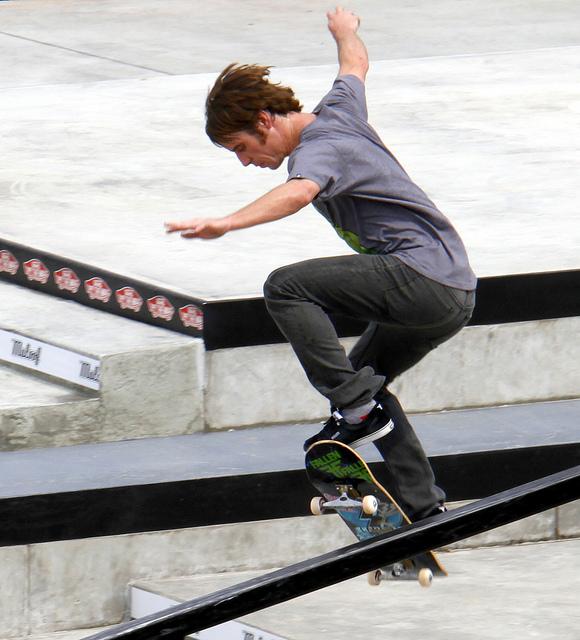Is he skating in a professional park?
Concise answer only. No. Is the person wearing a wristwatch?
Concise answer only. No. What is he doing?
Concise answer only. Skateboarding. What is the boy skating boarding on?
Answer briefly. Rail. 